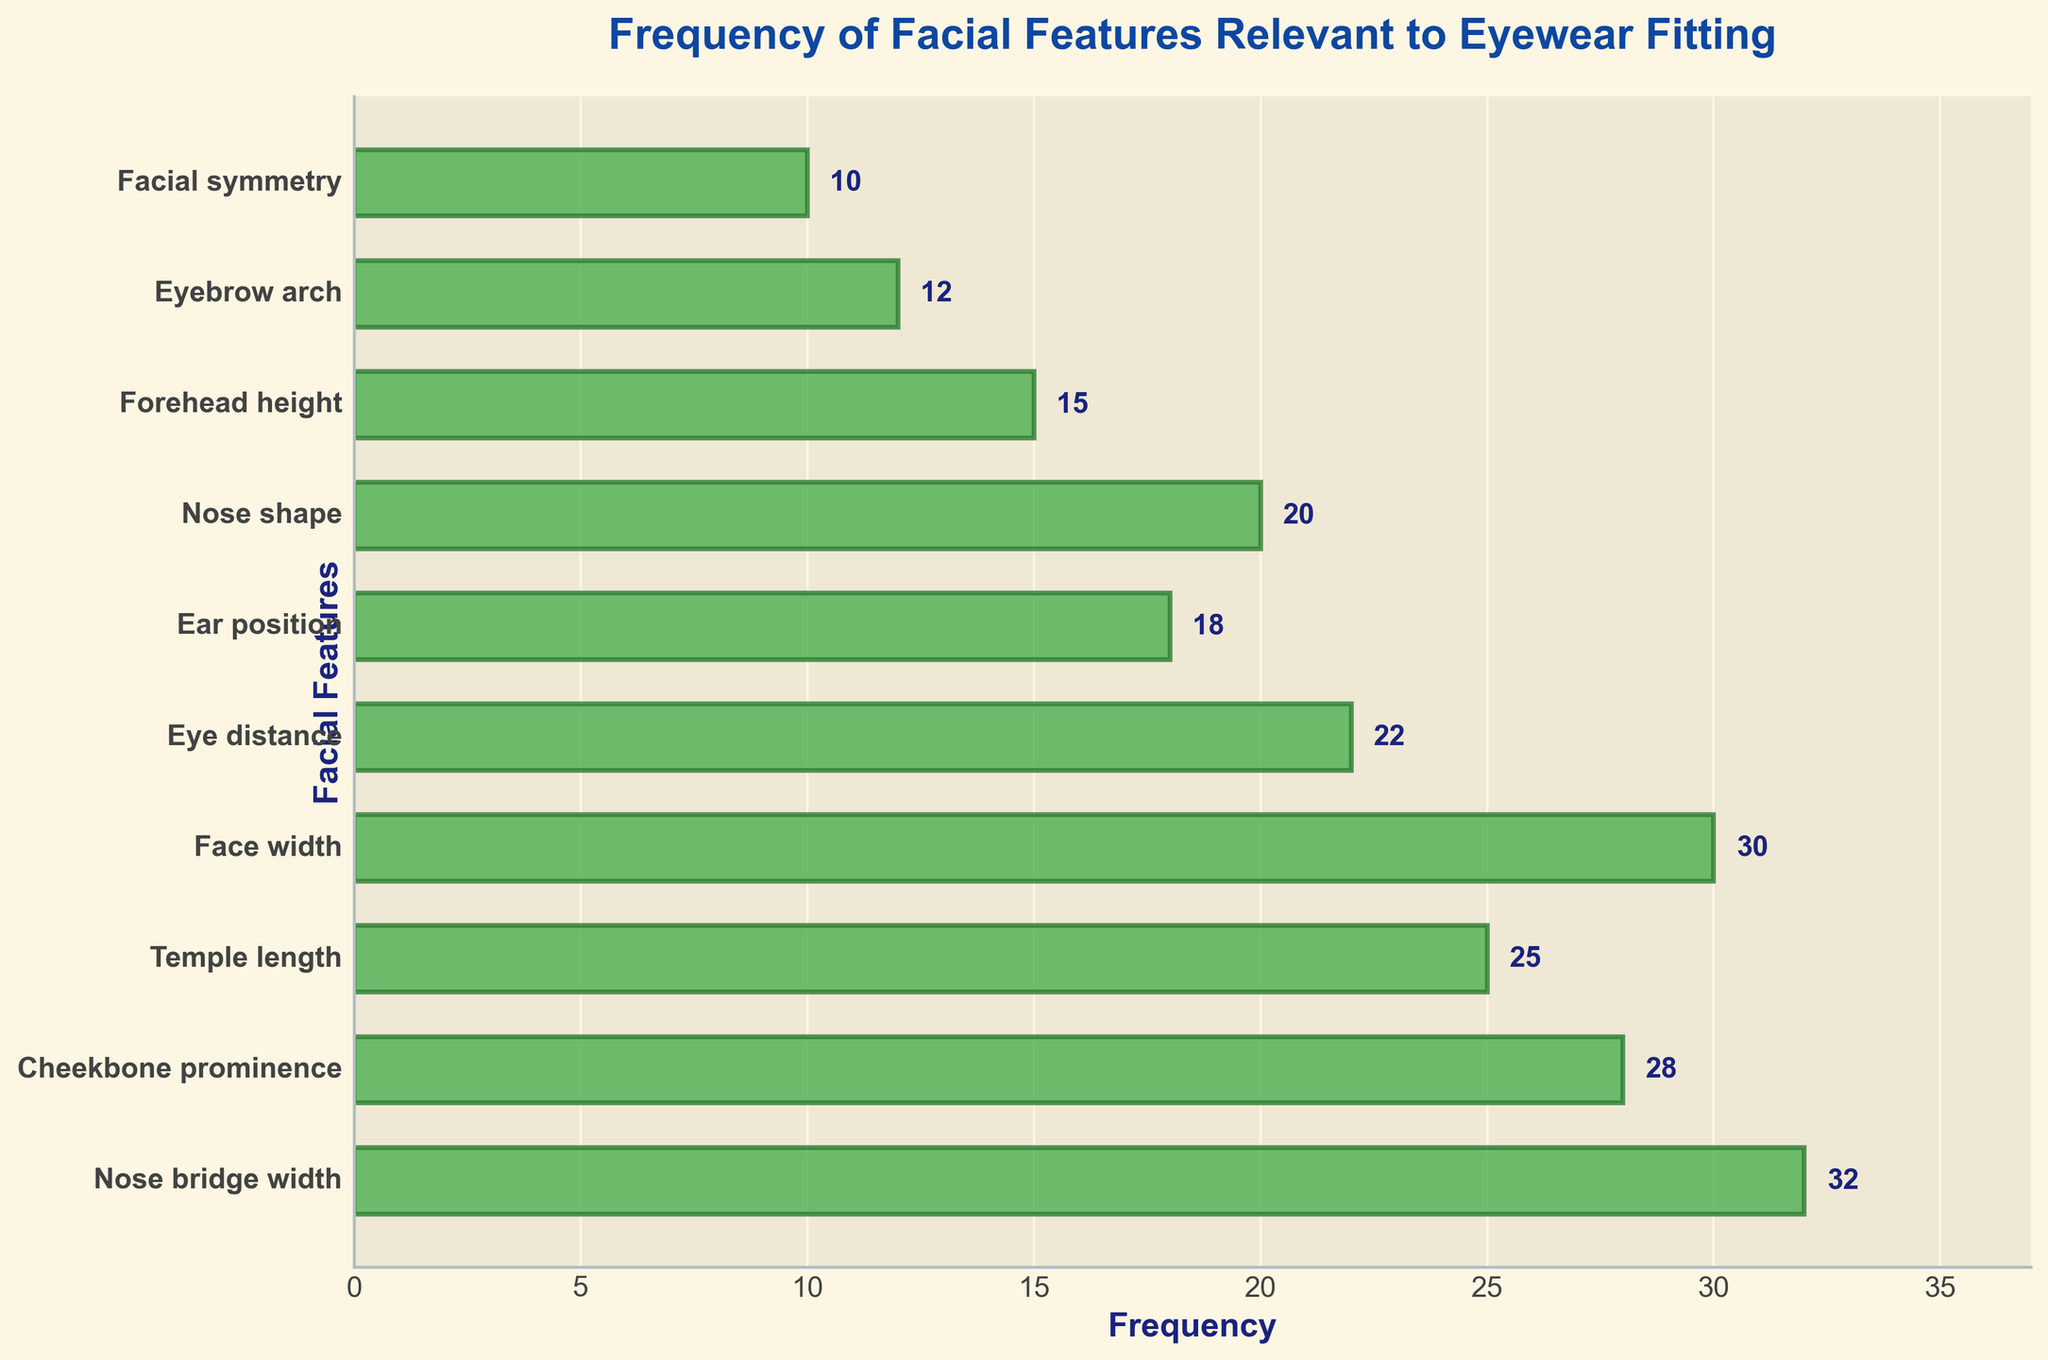What's the title of the figure? The title of the figure is located at the top center of the plot and is presented in bold text.
Answer: Frequency of Facial Features Relevant to Eyewear Fitting How many facial features are shown in the plot? The y-axis lists the facial features, and each bar corresponds to one feature. Counting the listed features will give the answer.
Answer: 10 Which facial feature has the highest frequency? By looking at the length of the horizontal bars, the longest bar represents the facial feature with the highest frequency.
Answer: Nose bridge width What is the frequency of 'Eye distance'? Look for the bar associated with 'Eye distance' on the y-axis, and read the corresponding value on the x-axis.
Answer: 22 What is the sum of the frequencies of 'Face width' and 'Nose shape'? Identify the frequencies of 'Face width' and 'Nose shape' then add these values together.
Answer: 30 + 20 = 50 Which feature has a frequency greater, 'Temple length' or 'Cheekbone prominence'? Compare the lengths of the bars associated with 'Temple length' and 'Cheekbone prominence'.
Answer: Cheekbone prominence How many facial features have a frequency less than 20? Count the bars where the frequency value on the x-axis is less than 20.
Answer: 4 What is the most common range of frequencies among the facial features? Determine the range by analyzing the frequency values: 10, 12, 15, 18, 20, 22, 25, 28, 30, 32, then observe the highest frequency range.
Answer: 20-30 Which has a higher frequency: 'Eyebrow arch' or 'Forehead height'? Look at the bars for 'Eyebrow arch' and 'Forehead height' and compare their lengths.
Answer: Forehead height Describe the visual appearance of the bars. The bars are horizontal, green with edge colors, and transparency. The text at the end of each bar shows the exact frequency.
Answer: Green horizontal bars with edge colors and frequency labels 